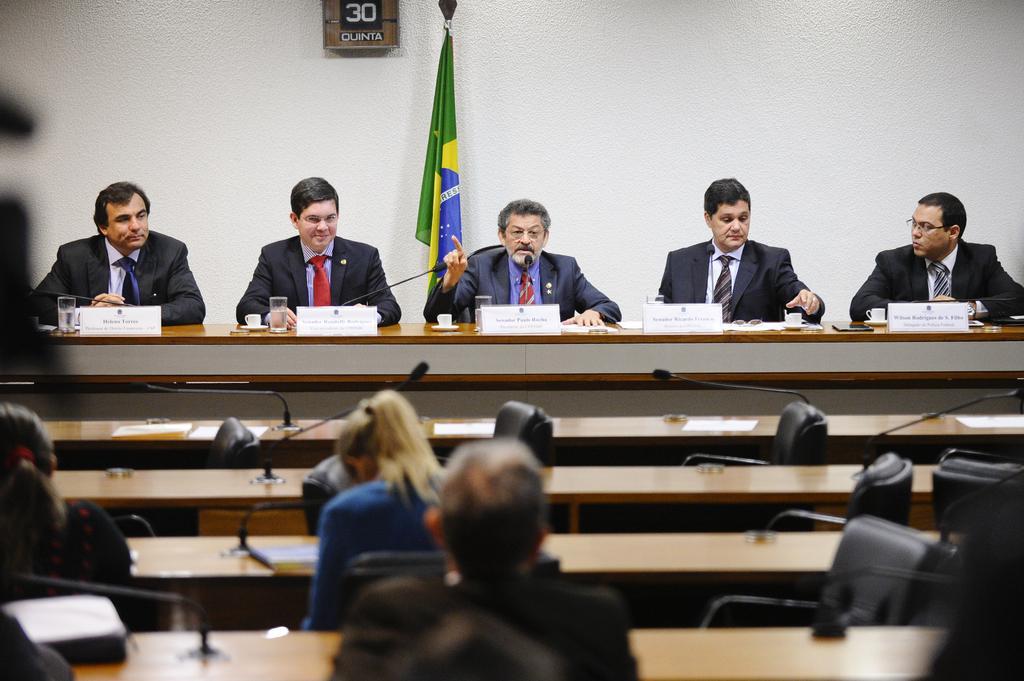In one or two sentences, can you explain what this image depicts? In the image we can see there are people who are sitting on chair and in front of them there are people who are sitting on benches and they are looking at each other. 